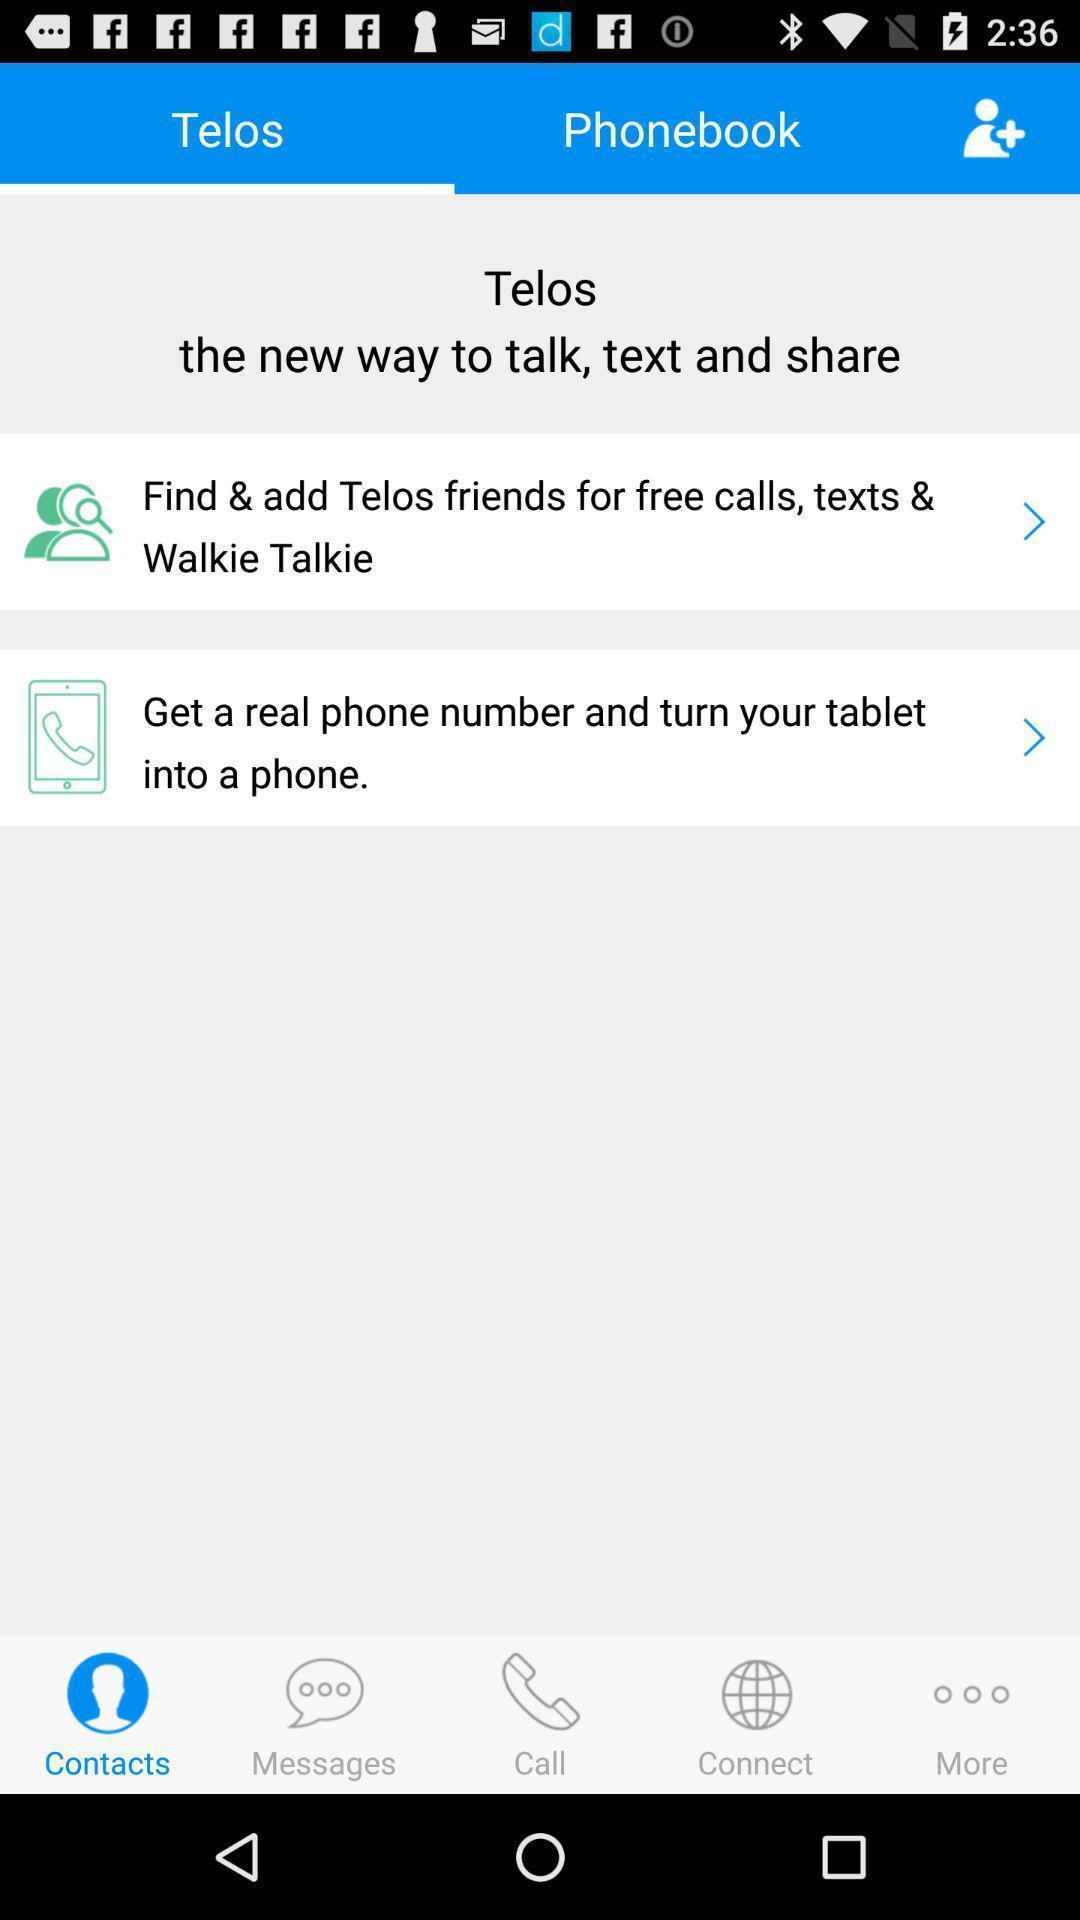Provide a description of this screenshot. Screen showing new way to connect friends in social app. 